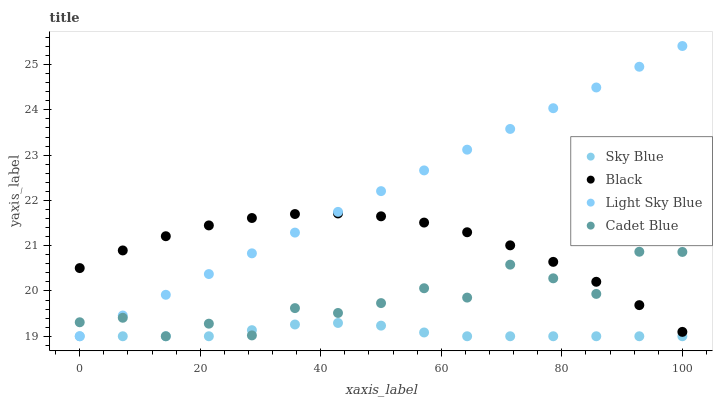Does Sky Blue have the minimum area under the curve?
Answer yes or no. Yes. Does Light Sky Blue have the maximum area under the curve?
Answer yes or no. Yes. Does Light Sky Blue have the minimum area under the curve?
Answer yes or no. No. Does Sky Blue have the maximum area under the curve?
Answer yes or no. No. Is Light Sky Blue the smoothest?
Answer yes or no. Yes. Is Cadet Blue the roughest?
Answer yes or no. Yes. Is Sky Blue the smoothest?
Answer yes or no. No. Is Sky Blue the roughest?
Answer yes or no. No. Does Cadet Blue have the lowest value?
Answer yes or no. Yes. Does Black have the lowest value?
Answer yes or no. No. Does Light Sky Blue have the highest value?
Answer yes or no. Yes. Does Sky Blue have the highest value?
Answer yes or no. No. Is Sky Blue less than Black?
Answer yes or no. Yes. Is Black greater than Sky Blue?
Answer yes or no. Yes. Does Black intersect Cadet Blue?
Answer yes or no. Yes. Is Black less than Cadet Blue?
Answer yes or no. No. Is Black greater than Cadet Blue?
Answer yes or no. No. Does Sky Blue intersect Black?
Answer yes or no. No. 